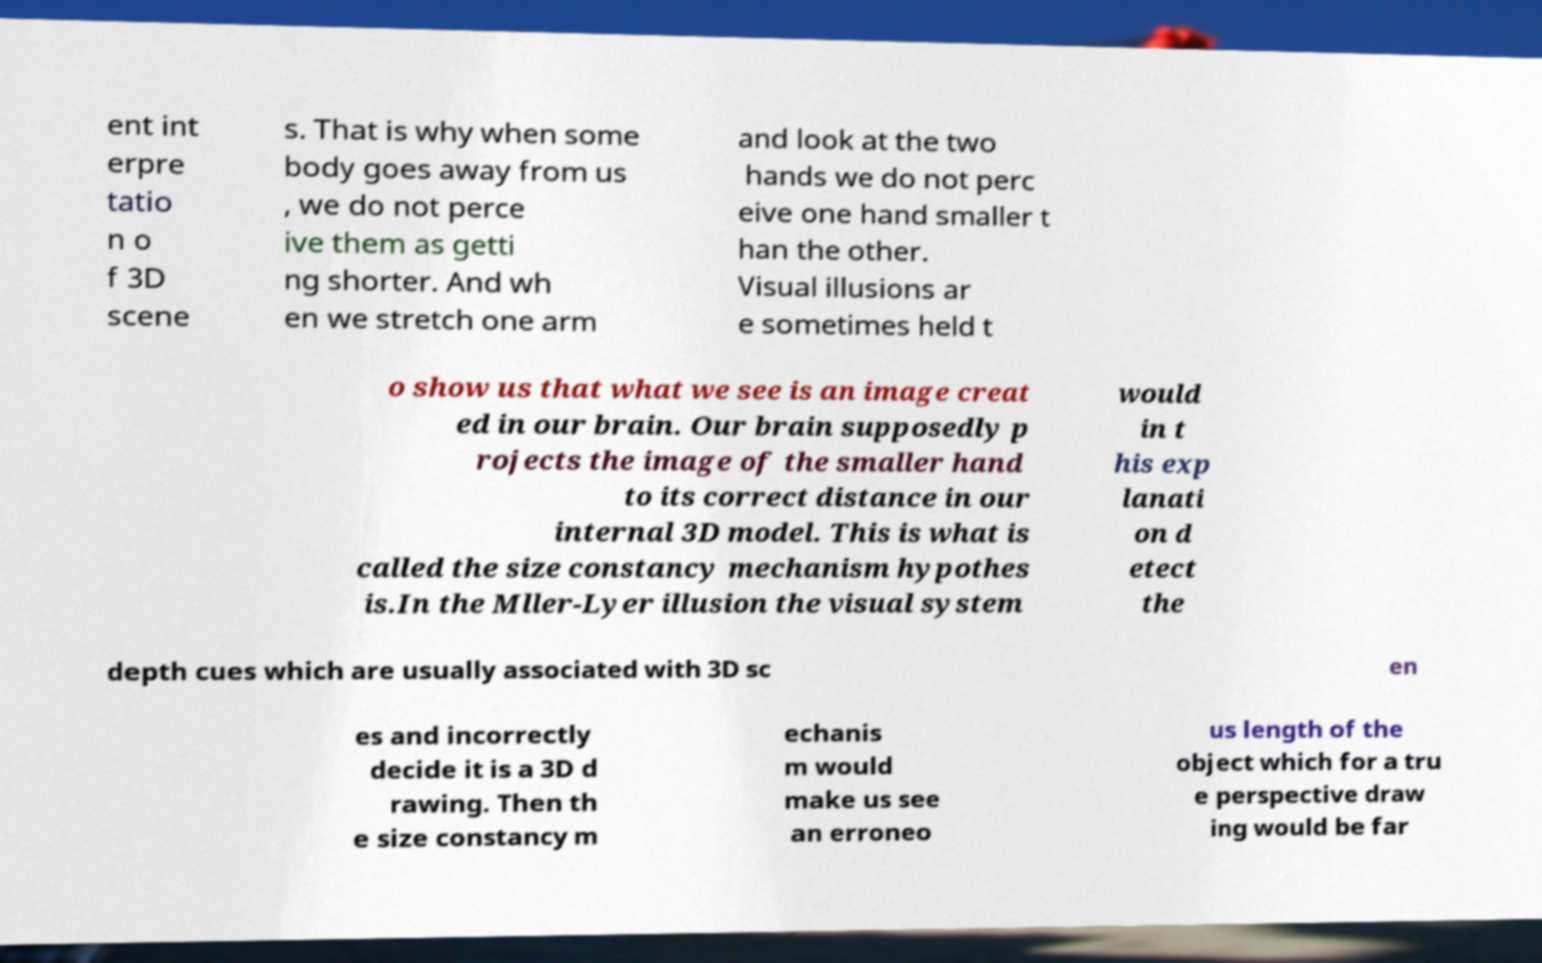I need the written content from this picture converted into text. Can you do that? ent int erpre tatio n o f 3D scene s. That is why when some body goes away from us , we do not perce ive them as getti ng shorter. And wh en we stretch one arm and look at the two hands we do not perc eive one hand smaller t han the other. Visual illusions ar e sometimes held t o show us that what we see is an image creat ed in our brain. Our brain supposedly p rojects the image of the smaller hand to its correct distance in our internal 3D model. This is what is called the size constancy mechanism hypothes is.In the Mller-Lyer illusion the visual system would in t his exp lanati on d etect the depth cues which are usually associated with 3D sc en es and incorrectly decide it is a 3D d rawing. Then th e size constancy m echanis m would make us see an erroneo us length of the object which for a tru e perspective draw ing would be far 